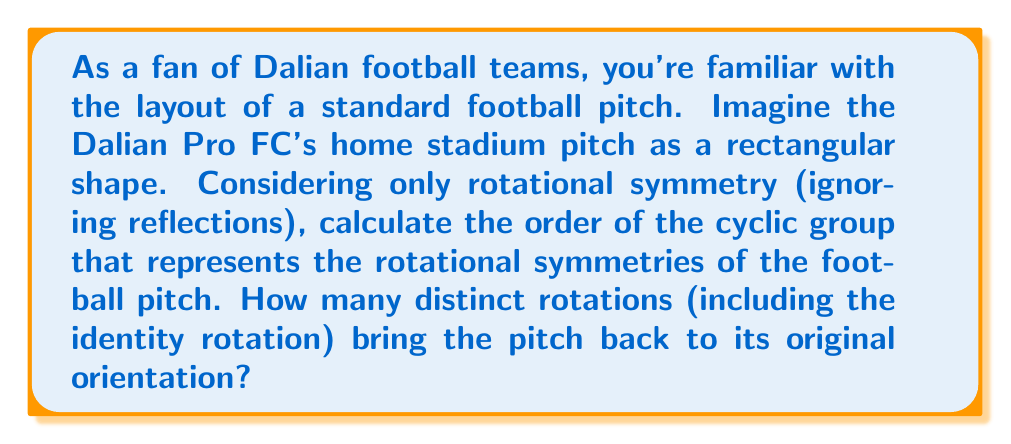Give your solution to this math problem. To solve this problem, we need to consider the rotational symmetries of a rectangle, which is the shape of a standard football pitch.

1) First, let's recall that the order of a cyclic group is the number of elements in the group.

2) For rotational symmetry, we're looking at how many times we can rotate the pitch and have it look the same as the original orientation.

3) A rectangle has two-fold rotational symmetry, meaning:

   - 0° rotation (identity): $$R_0$$
   - 180° rotation: $$R_{180}$$

4) These rotations form a cyclic group under composition. Let's call this group $$C_2$$.

5) The group operation table for $$C_2$$ is:

   $$\begin{array}{c|cc}
   \circ & R_0 & R_{180} \\
   \hline
   R_0 & R_0 & R_{180} \\
   R_{180} & R_{180} & R_0
   \end{array}$$

6) As we can see, there are only two elements in this group: the identity rotation (0°) and the 180° rotation.

7) Therefore, the order of the cyclic group representing the rotational symmetries of the football pitch is 2.

This means that there are 2 distinct rotations (including the identity rotation) that bring the pitch back to its original orientation.
Answer: The order of the cyclic group representing the rotational symmetries of a football pitch is 2. 